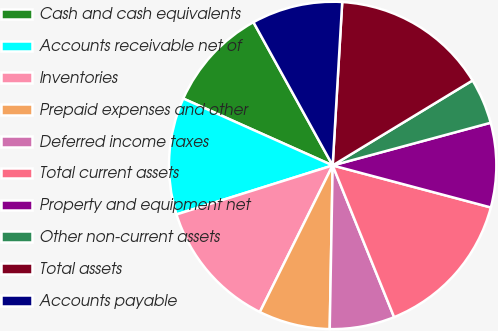Convert chart to OTSL. <chart><loc_0><loc_0><loc_500><loc_500><pie_chart><fcel>Cash and cash equivalents<fcel>Accounts receivable net of<fcel>Inventories<fcel>Prepaid expenses and other<fcel>Deferred income taxes<fcel>Total current assets<fcel>Property and equipment net<fcel>Other non-current assets<fcel>Total assets<fcel>Accounts payable<nl><fcel>10.26%<fcel>11.54%<fcel>12.82%<fcel>7.05%<fcel>6.41%<fcel>14.74%<fcel>8.33%<fcel>4.49%<fcel>15.38%<fcel>8.97%<nl></chart> 